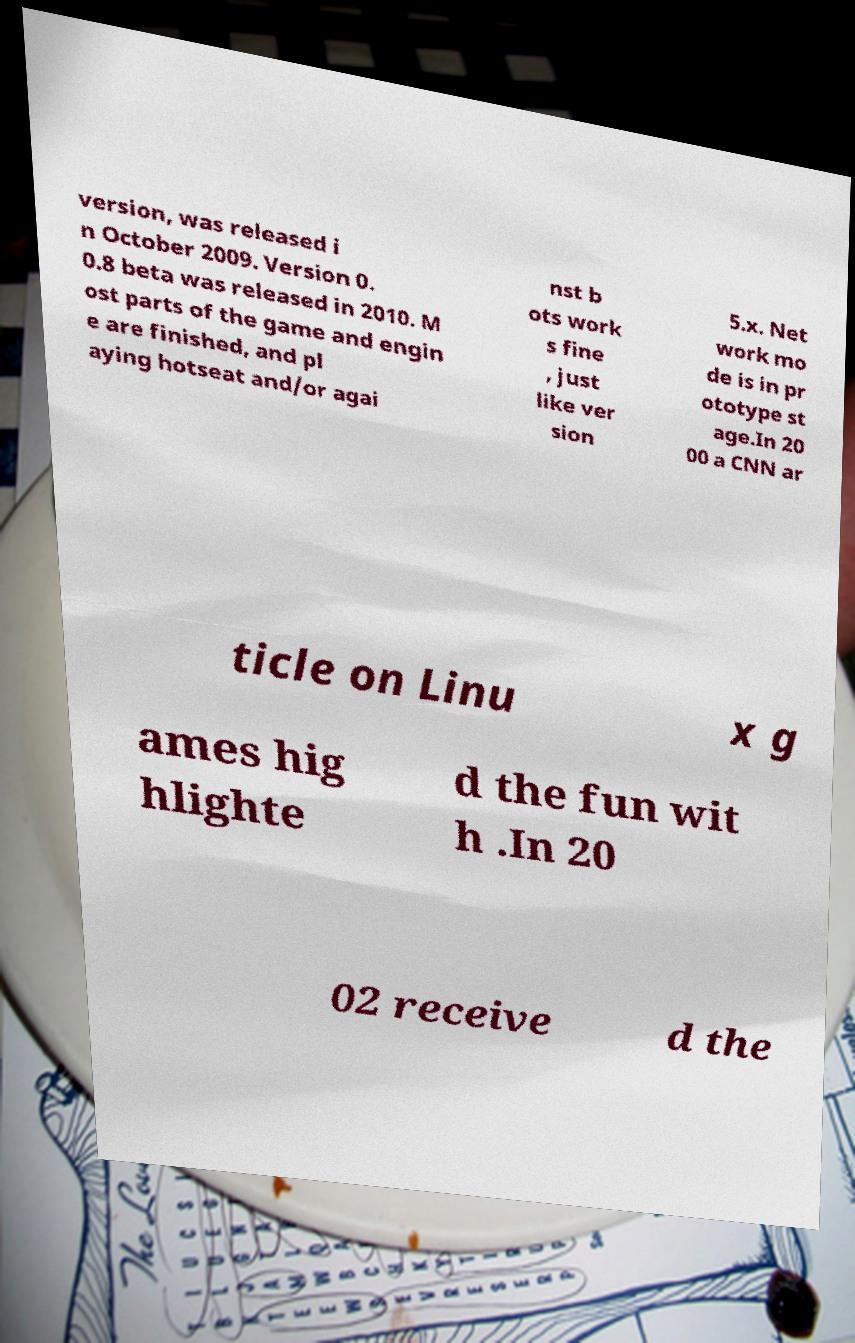Could you extract and type out the text from this image? version, was released i n October 2009. Version 0. 0.8 beta was released in 2010. M ost parts of the game and engin e are finished, and pl aying hotseat and/or agai nst b ots work s fine , just like ver sion 5.x. Net work mo de is in pr ototype st age.In 20 00 a CNN ar ticle on Linu x g ames hig hlighte d the fun wit h .In 20 02 receive d the 